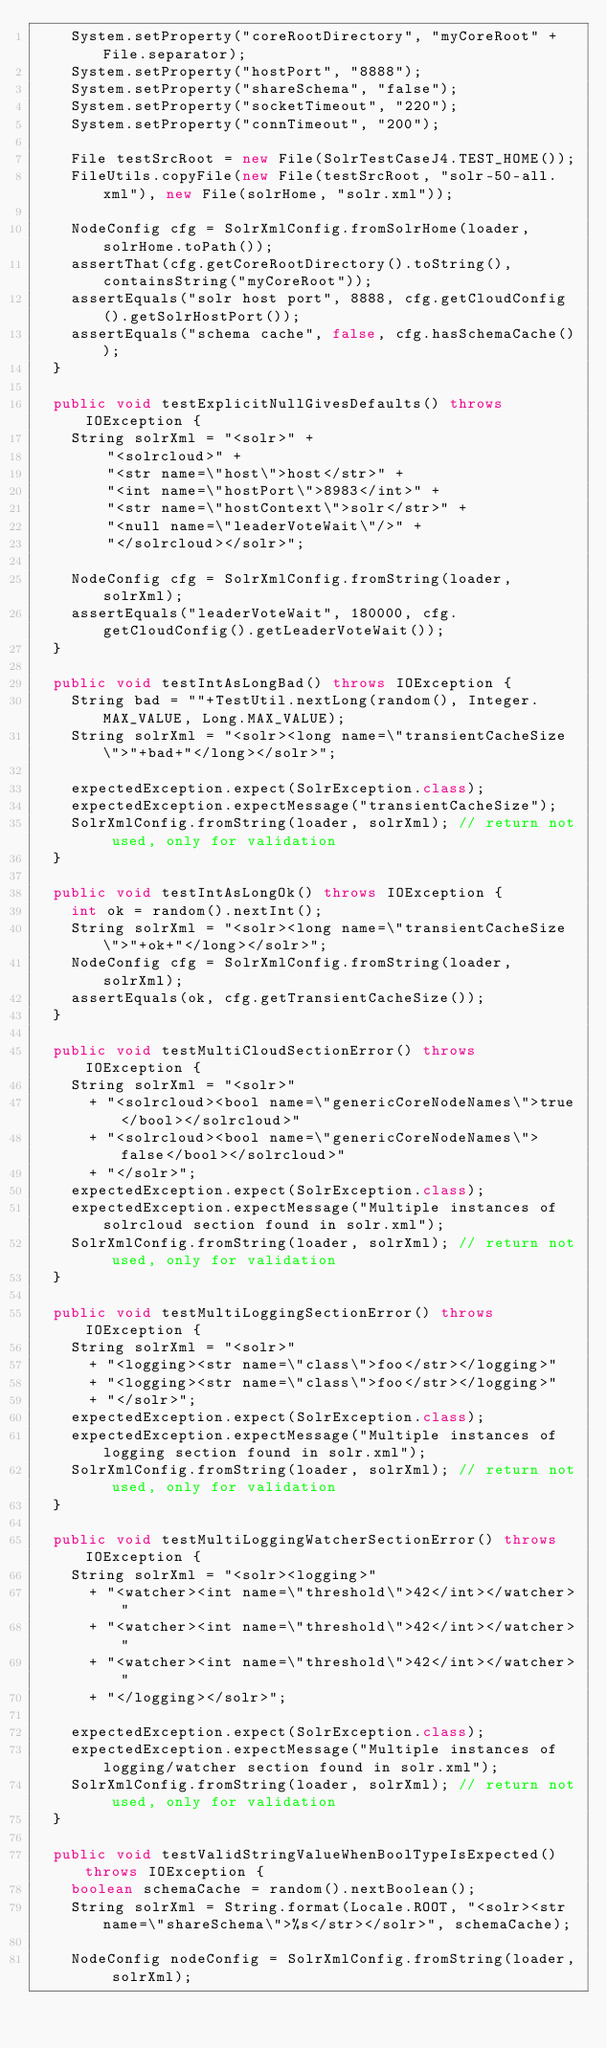Convert code to text. <code><loc_0><loc_0><loc_500><loc_500><_Java_>    System.setProperty("coreRootDirectory", "myCoreRoot" + File.separator);
    System.setProperty("hostPort", "8888");
    System.setProperty("shareSchema", "false");
    System.setProperty("socketTimeout", "220");
    System.setProperty("connTimeout", "200");

    File testSrcRoot = new File(SolrTestCaseJ4.TEST_HOME());
    FileUtils.copyFile(new File(testSrcRoot, "solr-50-all.xml"), new File(solrHome, "solr.xml"));

    NodeConfig cfg = SolrXmlConfig.fromSolrHome(loader, solrHome.toPath());
    assertThat(cfg.getCoreRootDirectory().toString(), containsString("myCoreRoot"));
    assertEquals("solr host port", 8888, cfg.getCloudConfig().getSolrHostPort());
    assertEquals("schema cache", false, cfg.hasSchemaCache());
  }

  public void testExplicitNullGivesDefaults() throws IOException {
    String solrXml = "<solr>" +
        "<solrcloud>" +
        "<str name=\"host\">host</str>" +
        "<int name=\"hostPort\">8983</int>" +
        "<str name=\"hostContext\">solr</str>" +
        "<null name=\"leaderVoteWait\"/>" +
        "</solrcloud></solr>";

    NodeConfig cfg = SolrXmlConfig.fromString(loader, solrXml);
    assertEquals("leaderVoteWait", 180000, cfg.getCloudConfig().getLeaderVoteWait());
  }

  public void testIntAsLongBad() throws IOException {
    String bad = ""+TestUtil.nextLong(random(), Integer.MAX_VALUE, Long.MAX_VALUE);
    String solrXml = "<solr><long name=\"transientCacheSize\">"+bad+"</long></solr>";

    expectedException.expect(SolrException.class);
    expectedException.expectMessage("transientCacheSize");
    SolrXmlConfig.fromString(loader, solrXml); // return not used, only for validation
  }

  public void testIntAsLongOk() throws IOException {
    int ok = random().nextInt();
    String solrXml = "<solr><long name=\"transientCacheSize\">"+ok+"</long></solr>";
    NodeConfig cfg = SolrXmlConfig.fromString(loader, solrXml);
    assertEquals(ok, cfg.getTransientCacheSize());
  }

  public void testMultiCloudSectionError() throws IOException {
    String solrXml = "<solr>"
      + "<solrcloud><bool name=\"genericCoreNodeNames\">true</bool></solrcloud>"
      + "<solrcloud><bool name=\"genericCoreNodeNames\">false</bool></solrcloud>"
      + "</solr>";
    expectedException.expect(SolrException.class);
    expectedException.expectMessage("Multiple instances of solrcloud section found in solr.xml");
    SolrXmlConfig.fromString(loader, solrXml); // return not used, only for validation
  }

  public void testMultiLoggingSectionError() throws IOException {
    String solrXml = "<solr>"
      + "<logging><str name=\"class\">foo</str></logging>"
      + "<logging><str name=\"class\">foo</str></logging>"
      + "</solr>";
    expectedException.expect(SolrException.class);
    expectedException.expectMessage("Multiple instances of logging section found in solr.xml");
    SolrXmlConfig.fromString(loader, solrXml); // return not used, only for validation
  }

  public void testMultiLoggingWatcherSectionError() throws IOException {
    String solrXml = "<solr><logging>"
      + "<watcher><int name=\"threshold\">42</int></watcher>"
      + "<watcher><int name=\"threshold\">42</int></watcher>"
      + "<watcher><int name=\"threshold\">42</int></watcher>"
      + "</logging></solr>";

    expectedException.expect(SolrException.class);
    expectedException.expectMessage("Multiple instances of logging/watcher section found in solr.xml");
    SolrXmlConfig.fromString(loader, solrXml); // return not used, only for validation
  }
 
  public void testValidStringValueWhenBoolTypeIsExpected() throws IOException {
    boolean schemaCache = random().nextBoolean();
    String solrXml = String.format(Locale.ROOT, "<solr><str name=\"shareSchema\">%s</str></solr>", schemaCache);

    NodeConfig nodeConfig = SolrXmlConfig.fromString(loader, solrXml);</code> 